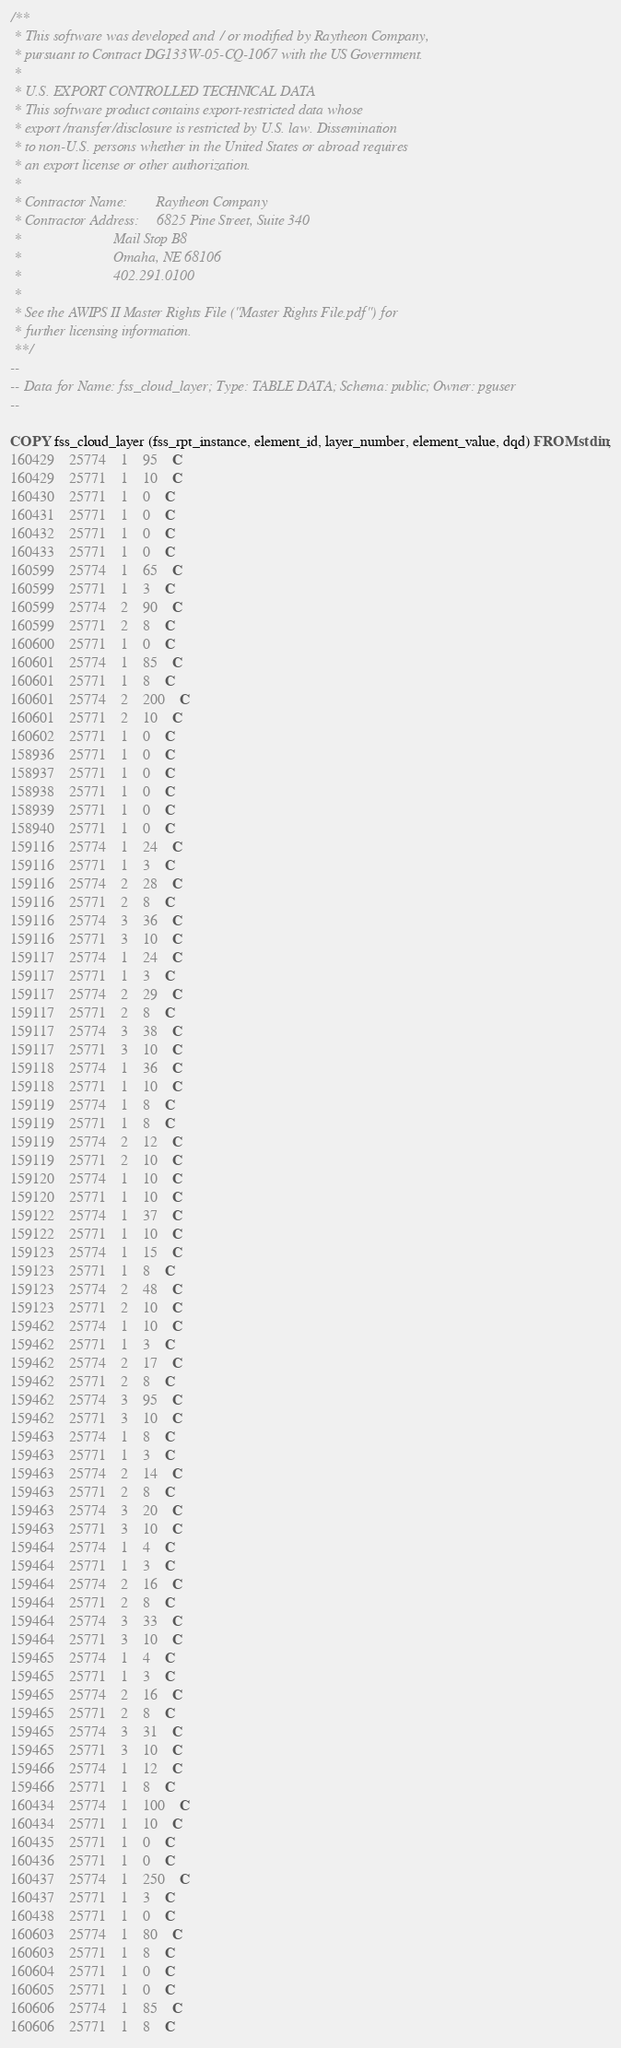Convert code to text. <code><loc_0><loc_0><loc_500><loc_500><_SQL_>/**
 * This software was developed and / or modified by Raytheon Company,
 * pursuant to Contract DG133W-05-CQ-1067 with the US Government.
 * 
 * U.S. EXPORT CONTROLLED TECHNICAL DATA
 * This software product contains export-restricted data whose
 * export/transfer/disclosure is restricted by U.S. law. Dissemination
 * to non-U.S. persons whether in the United States or abroad requires
 * an export license or other authorization.
 * 
 * Contractor Name:        Raytheon Company
 * Contractor Address:     6825 Pine Street, Suite 340
 *                         Mail Stop B8
 *                         Omaha, NE 68106
 *                         402.291.0100
 * 
 * See the AWIPS II Master Rights File ("Master Rights File.pdf") for
 * further licensing information.
 **/
--
-- Data for Name: fss_cloud_layer; Type: TABLE DATA; Schema: public; Owner: pguser
--

COPY fss_cloud_layer (fss_rpt_instance, element_id, layer_number, element_value, dqd) FROM stdin;
160429	25774	1	95	C
160429	25771	1	10	C
160430	25771	1	0	C
160431	25771	1	0	C
160432	25771	1	0	C
160433	25771	1	0	C
160599	25774	1	65	C
160599	25771	1	3	C
160599	25774	2	90	C
160599	25771	2	8	C
160600	25771	1	0	C
160601	25774	1	85	C
160601	25771	1	8	C
160601	25774	2	200	C
160601	25771	2	10	C
160602	25771	1	0	C
158936	25771	1	0	C
158937	25771	1	0	C
158938	25771	1	0	C
158939	25771	1	0	C
158940	25771	1	0	C
159116	25774	1	24	C
159116	25771	1	3	C
159116	25774	2	28	C
159116	25771	2	8	C
159116	25774	3	36	C
159116	25771	3	10	C
159117	25774	1	24	C
159117	25771	1	3	C
159117	25774	2	29	C
159117	25771	2	8	C
159117	25774	3	38	C
159117	25771	3	10	C
159118	25774	1	36	C
159118	25771	1	10	C
159119	25774	1	8	C
159119	25771	1	8	C
159119	25774	2	12	C
159119	25771	2	10	C
159120	25774	1	10	C
159120	25771	1	10	C
159122	25774	1	37	C
159122	25771	1	10	C
159123	25774	1	15	C
159123	25771	1	8	C
159123	25774	2	48	C
159123	25771	2	10	C
159462	25774	1	10	C
159462	25771	1	3	C
159462	25774	2	17	C
159462	25771	2	8	C
159462	25774	3	95	C
159462	25771	3	10	C
159463	25774	1	8	C
159463	25771	1	3	C
159463	25774	2	14	C
159463	25771	2	8	C
159463	25774	3	20	C
159463	25771	3	10	C
159464	25774	1	4	C
159464	25771	1	3	C
159464	25774	2	16	C
159464	25771	2	8	C
159464	25774	3	33	C
159464	25771	3	10	C
159465	25774	1	4	C
159465	25771	1	3	C
159465	25774	2	16	C
159465	25771	2	8	C
159465	25774	3	31	C
159465	25771	3	10	C
159466	25774	1	12	C
159466	25771	1	8	C
160434	25774	1	100	C
160434	25771	1	10	C
160435	25771	1	0	C
160436	25771	1	0	C
160437	25774	1	250	C
160437	25771	1	3	C
160438	25771	1	0	C
160603	25774	1	80	C
160603	25771	1	8	C
160604	25771	1	0	C
160605	25771	1	0	C
160606	25774	1	85	C
160606	25771	1	8	C</code> 